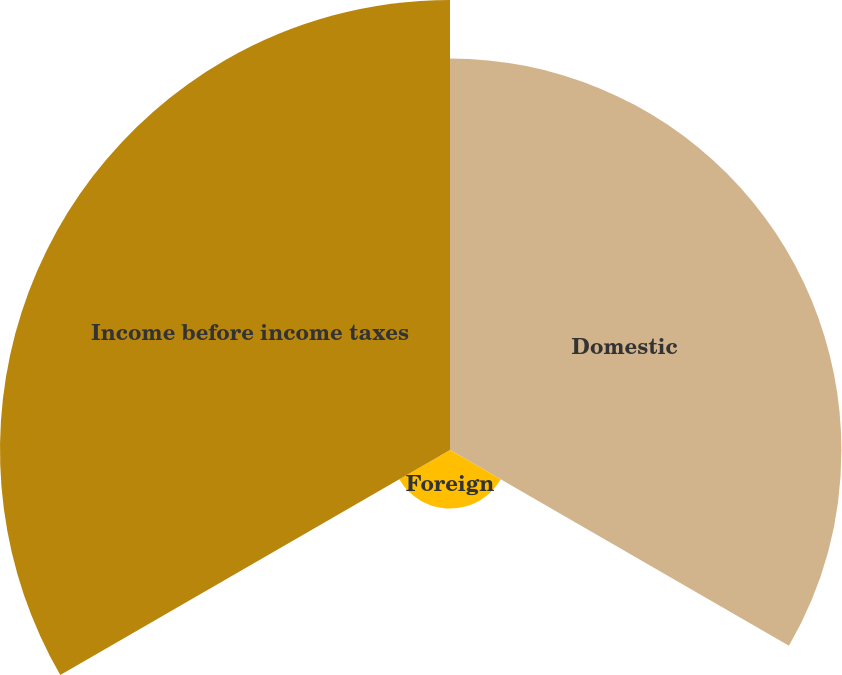Convert chart to OTSL. <chart><loc_0><loc_0><loc_500><loc_500><pie_chart><fcel>Domestic<fcel>Foreign<fcel>Income before income taxes<nl><fcel>43.49%<fcel>6.51%<fcel>50.0%<nl></chart> 